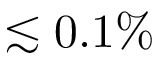Convert formula to latex. <formula><loc_0><loc_0><loc_500><loc_500>\lesssim 0 . 1 \%</formula> 